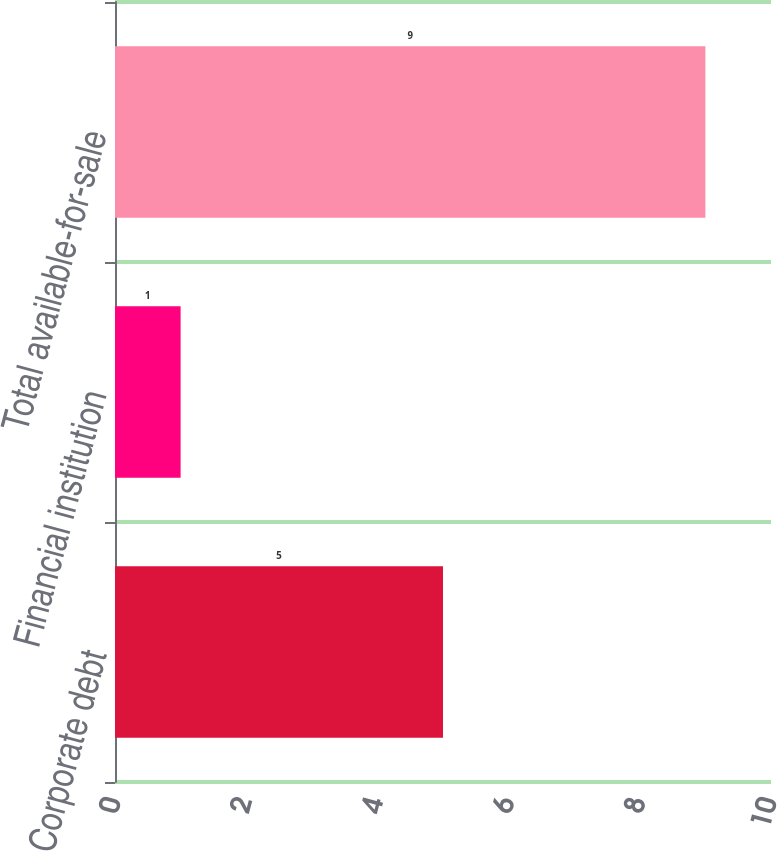Convert chart to OTSL. <chart><loc_0><loc_0><loc_500><loc_500><bar_chart><fcel>Corporate debt<fcel>Financial institution<fcel>Total available-for-sale<nl><fcel>5<fcel>1<fcel>9<nl></chart> 